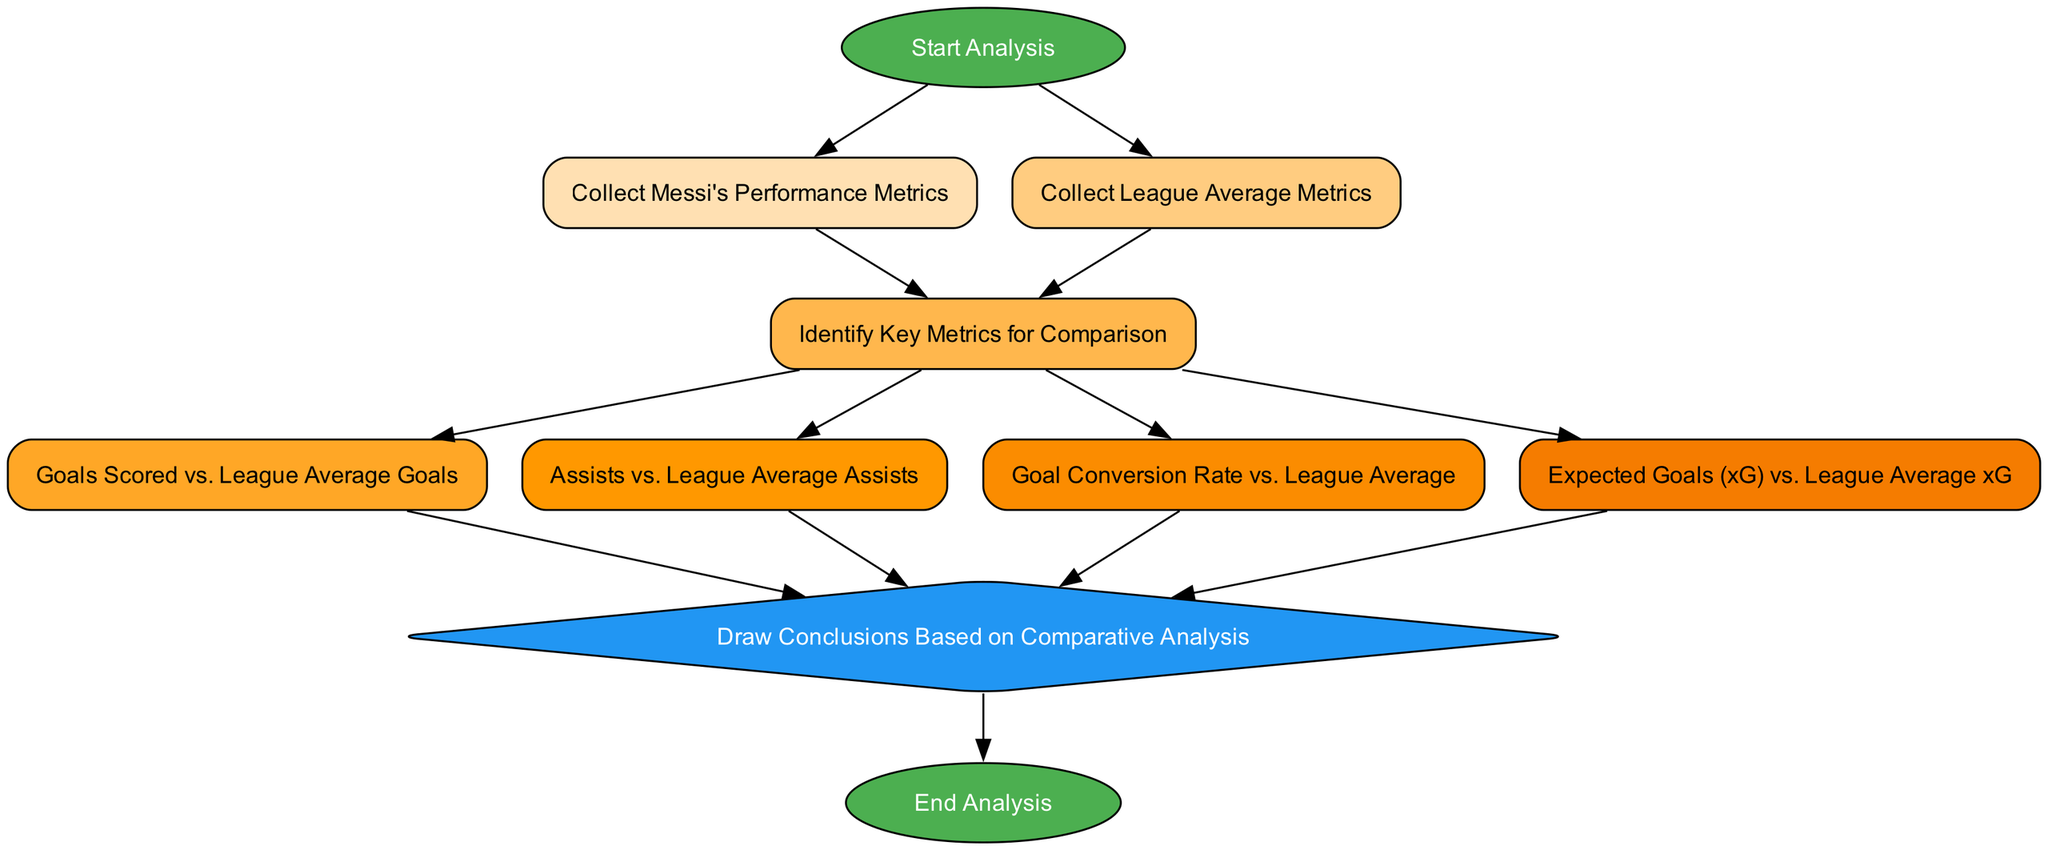What is the starting node of the flow chart? The flow chart begins with the node labeled "Start Analysis".
Answer: Start Analysis How many key metrics are identified for comparison? The diagram defines four key metrics that are identified for comparison: Goals, Assists, Goal Conversion Rate, and Expected Goals (xG).
Answer: Four Which node follows "Collect Messi's Performance Metrics"? After "Collect Messi's Performance Metrics", the next node is "Identify Key Metrics for Comparison".
Answer: Identify Key Metrics for Comparison What is the terminal node of the flow chart? The flow chart ends with the node labeled "End Analysis".
Answer: End Analysis What type of node is "Draw Conclusions Based on Comparative Analysis"? This node is a diamond shape, indicating that it represents a decision or conclusion point in the analysis process.
Answer: Diamond How many edges lead to the conclusion node? There are four edges that lead into the conclusion node: from Goals Scored, Assists, Goal Conversion Rate, and Expected Goals analyses.
Answer: Four What do the two parallel starting nodes indicate? The two starting nodes indicate that the data collection for Messi's metrics and the league averages occur simultaneously before proceeding to identify key metrics.
Answer: Simultaneous data collection Which nodes must be traversed to assess goal conversion rate compared to league averages? To assess goal conversion rate, the flow must go from "Identify Key Metrics for Comparison" to "Goal Conversion Rate vs. League Average".
Answer: Two nodes What relationship exists between the "Assists" and "Conclusion" nodes? The edge from "Assists" to "Conclusion" indicates that assists contribute to the overall conclusion drawn about Messi's performance relative to the league averages.
Answer: Contributory relationship 